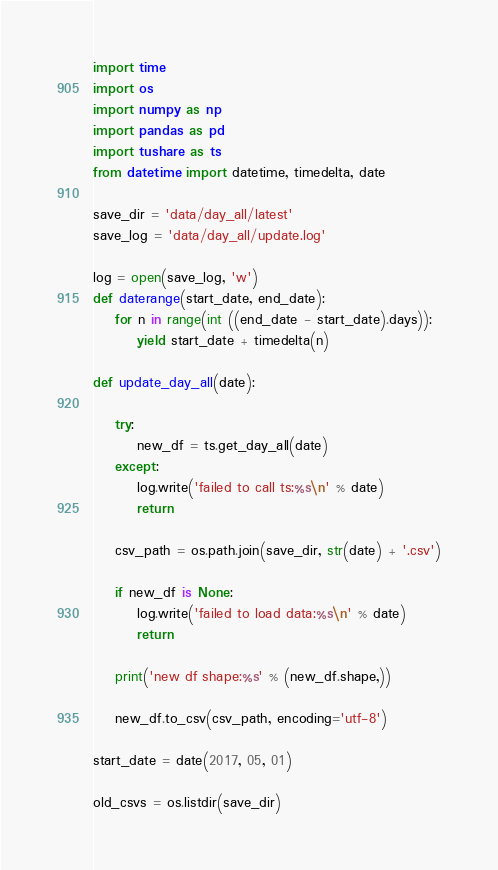Convert code to text. <code><loc_0><loc_0><loc_500><loc_500><_Python_>import time
import os
import numpy as np
import pandas as pd
import tushare as ts
from datetime import datetime, timedelta, date

save_dir = 'data/day_all/latest'
save_log = 'data/day_all/update.log'

log = open(save_log, 'w')
def daterange(start_date, end_date):
    for n in range(int ((end_date - start_date).days)):
        yield start_date + timedelta(n)

def update_day_all(date):

    try:
        new_df = ts.get_day_all(date)
    except:
        log.write('failed to call ts:%s\n' % date)
        return

    csv_path = os.path.join(save_dir, str(date) + '.csv')

    if new_df is None:
        log.write('failed to load data:%s\n' % date)
        return

    print('new df shape:%s' % (new_df.shape,))

    new_df.to_csv(csv_path, encoding='utf-8')

start_date = date(2017, 05, 01)

old_csvs = os.listdir(save_dir)</code> 